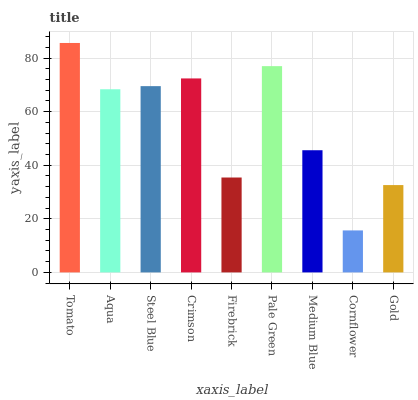Is Aqua the minimum?
Answer yes or no. No. Is Aqua the maximum?
Answer yes or no. No. Is Tomato greater than Aqua?
Answer yes or no. Yes. Is Aqua less than Tomato?
Answer yes or no. Yes. Is Aqua greater than Tomato?
Answer yes or no. No. Is Tomato less than Aqua?
Answer yes or no. No. Is Aqua the high median?
Answer yes or no. Yes. Is Aqua the low median?
Answer yes or no. Yes. Is Cornflower the high median?
Answer yes or no. No. Is Medium Blue the low median?
Answer yes or no. No. 